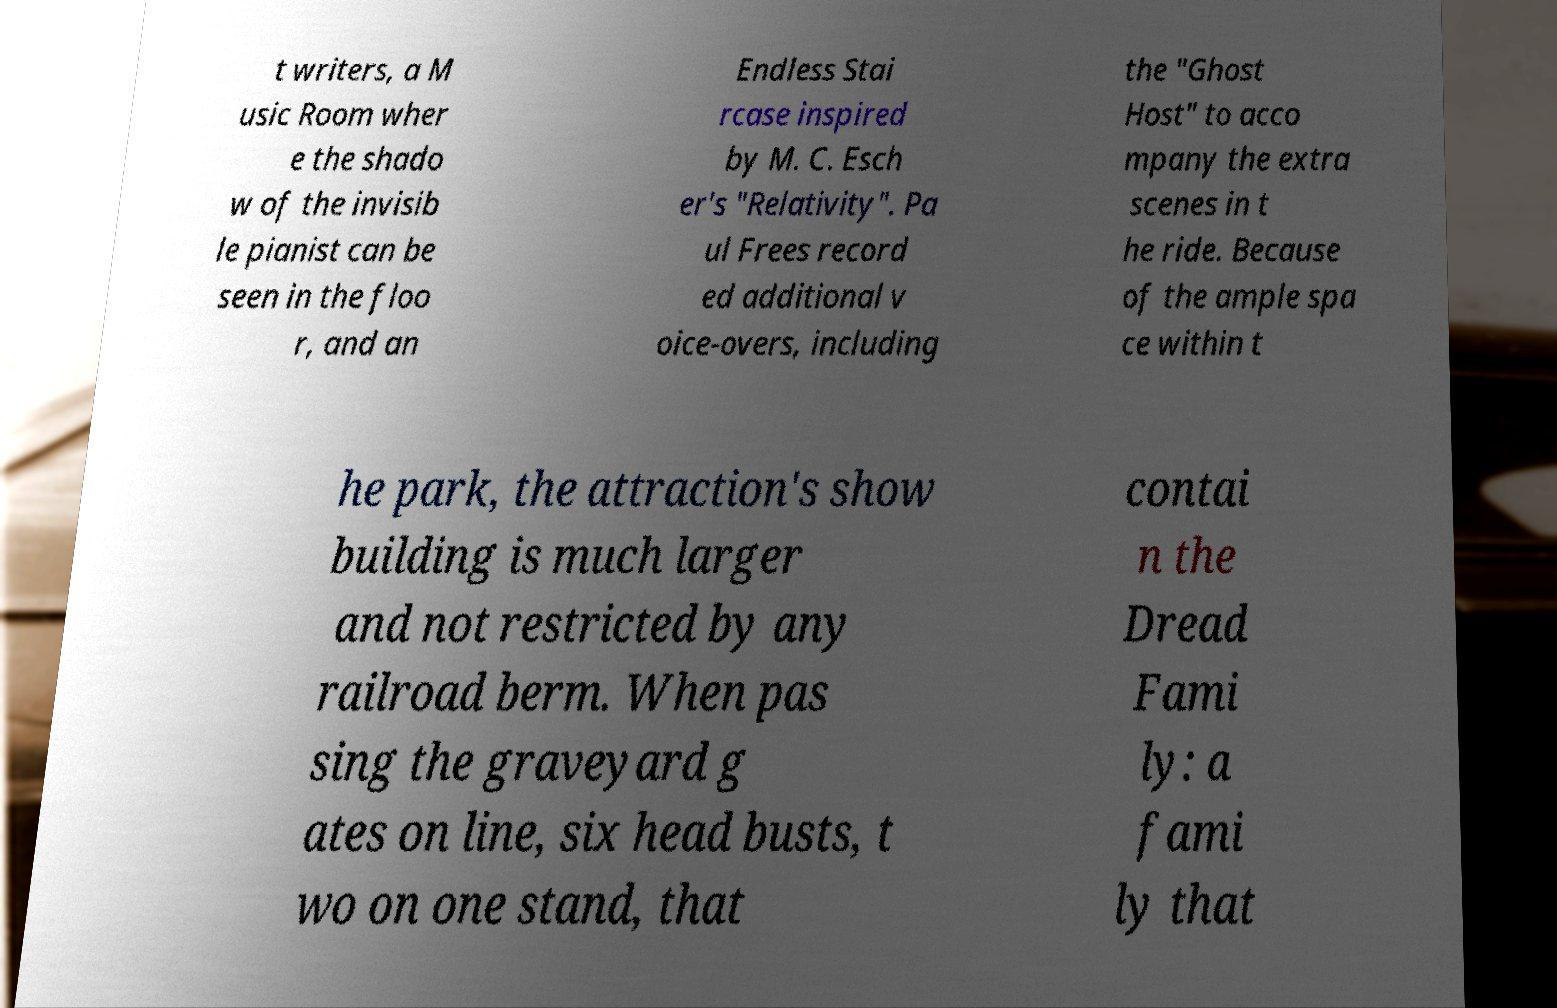Please identify and transcribe the text found in this image. t writers, a M usic Room wher e the shado w of the invisib le pianist can be seen in the floo r, and an Endless Stai rcase inspired by M. C. Esch er's "Relativity". Pa ul Frees record ed additional v oice-overs, including the "Ghost Host" to acco mpany the extra scenes in t he ride. Because of the ample spa ce within t he park, the attraction's show building is much larger and not restricted by any railroad berm. When pas sing the graveyard g ates on line, six head busts, t wo on one stand, that contai n the Dread Fami ly: a fami ly that 